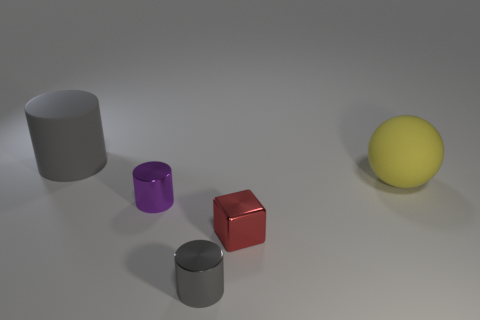Add 2 yellow objects. How many objects exist? 7 Subtract all cylinders. How many objects are left? 2 Subtract all small gray cylinders. Subtract all tiny metallic cylinders. How many objects are left? 2 Add 1 tiny purple objects. How many tiny purple objects are left? 2 Add 1 gray matte cubes. How many gray matte cubes exist? 1 Subtract 0 green cylinders. How many objects are left? 5 